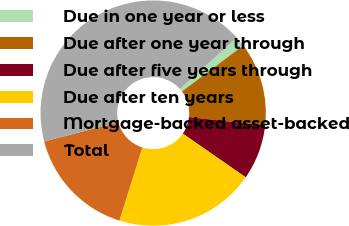Convert chart. <chart><loc_0><loc_0><loc_500><loc_500><pie_chart><fcel>Due in one year or less<fcel>Due after one year through<fcel>Due after five years through<fcel>Due after ten years<fcel>Mortgage-backed asset-backed<fcel>Total<nl><fcel>1.42%<fcel>12.0%<fcel>7.9%<fcel>20.19%<fcel>16.1%<fcel>42.38%<nl></chart> 